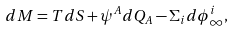<formula> <loc_0><loc_0><loc_500><loc_500>d M = T d S + \psi ^ { A } d Q _ { A } - \Sigma _ { i } d \phi ^ { i } _ { \infty } ,</formula> 